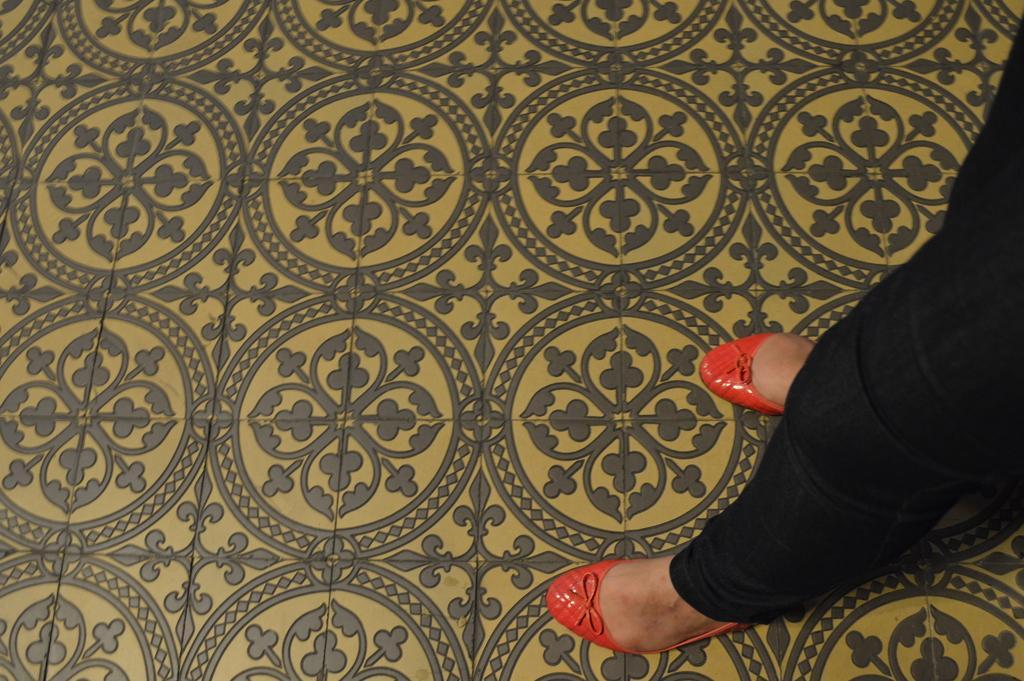In one or two sentences, can you explain what this image depicts? In this image we can see a person wearing black pant and red shoes is standing on the floor with different design. 